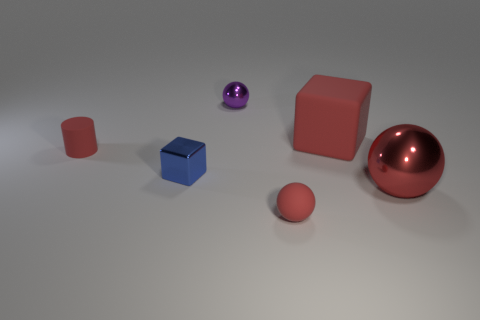Is the number of things to the right of the big matte thing less than the number of small cubes to the right of the tiny blue object?
Make the answer very short. No. What is the material of the object that is right of the large red rubber cube?
Provide a succinct answer. Metal. What size is the rubber block that is the same color as the big metallic sphere?
Your response must be concise. Large. Are there any objects that have the same size as the rubber sphere?
Ensure brevity in your answer.  Yes. Does the purple object have the same shape as the red object on the right side of the rubber block?
Make the answer very short. Yes. There is a shiny sphere in front of the tiny purple sphere; is it the same size as the red matte block behind the tiny blue shiny block?
Provide a succinct answer. Yes. What number of other things are the same shape as the purple object?
Ensure brevity in your answer.  2. What material is the sphere behind the metallic thing that is right of the large block?
Give a very brief answer. Metal. What number of metal objects are red balls or tiny purple spheres?
Provide a short and direct response. 2. Is there any other thing that has the same material as the small cylinder?
Make the answer very short. Yes. 